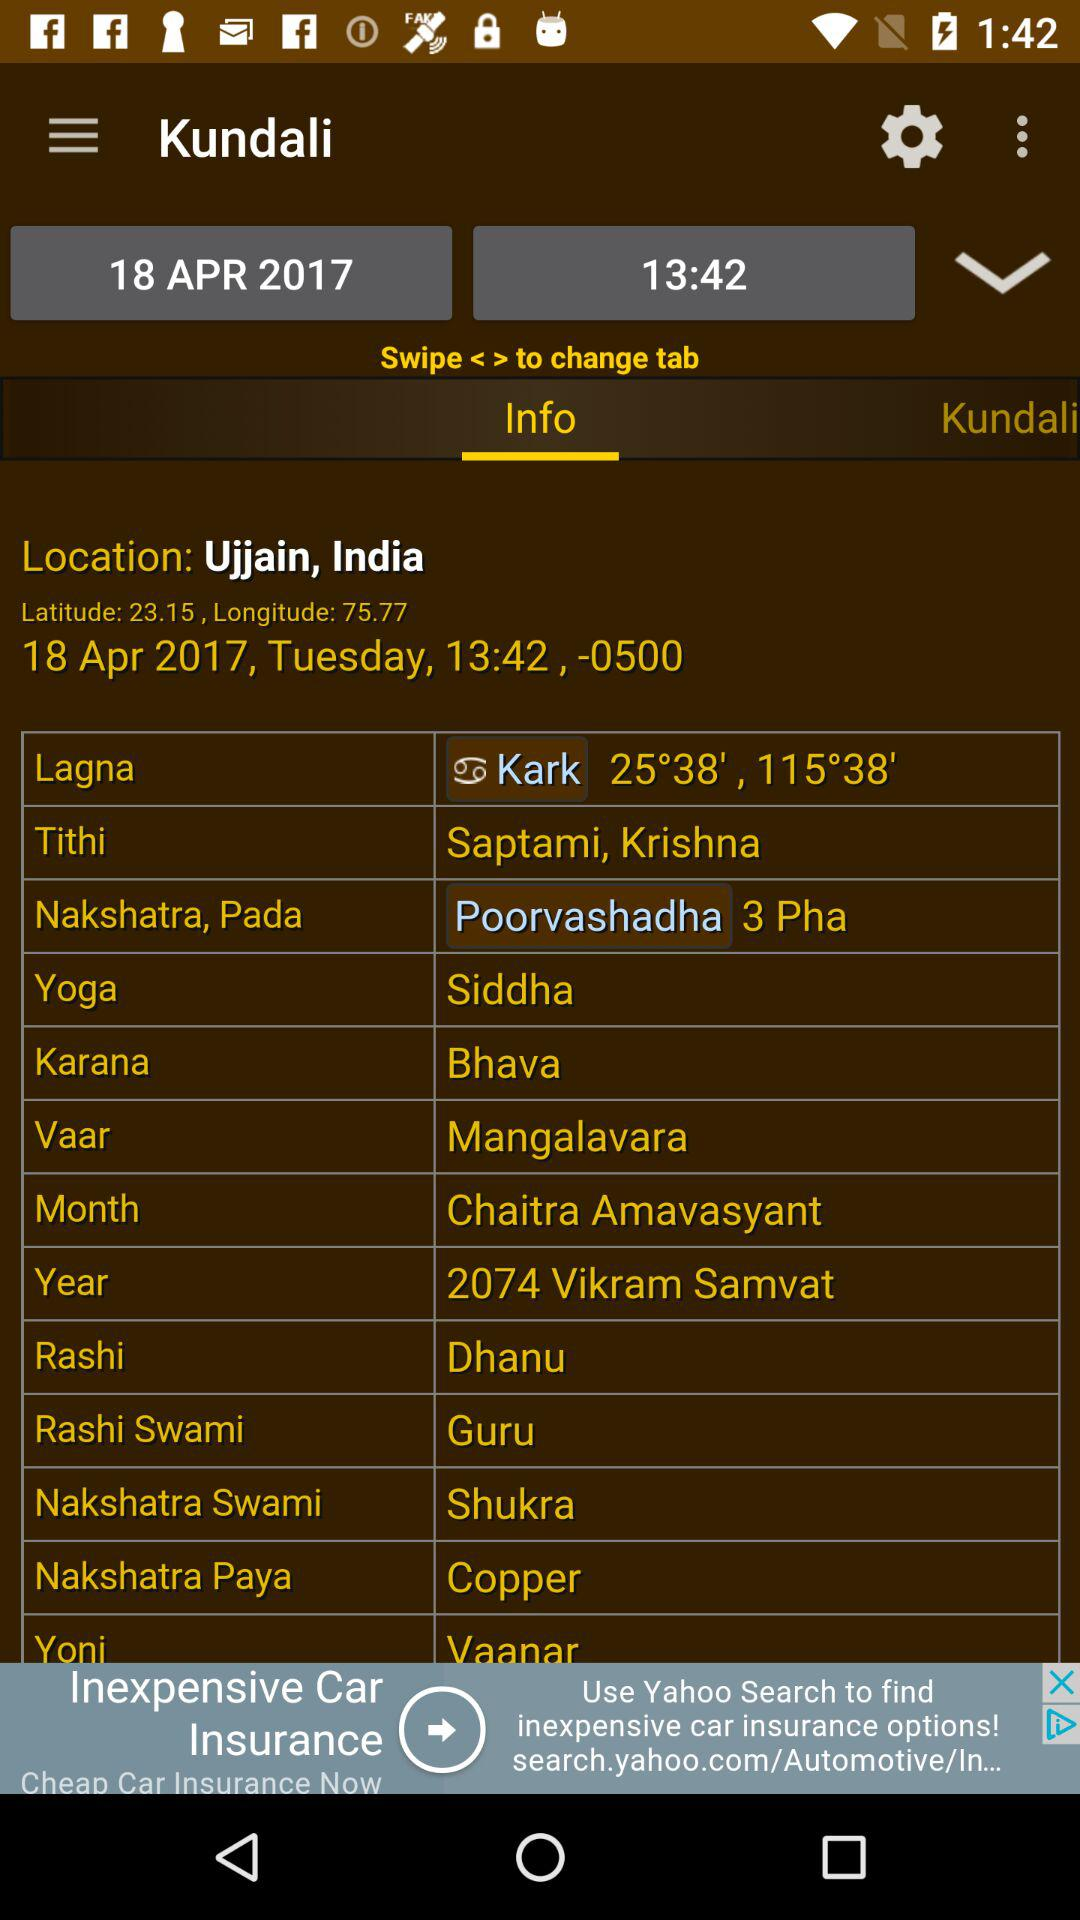What is the difference between the longitude and latitude of the location?
Answer the question using a single word or phrase. 52.62 